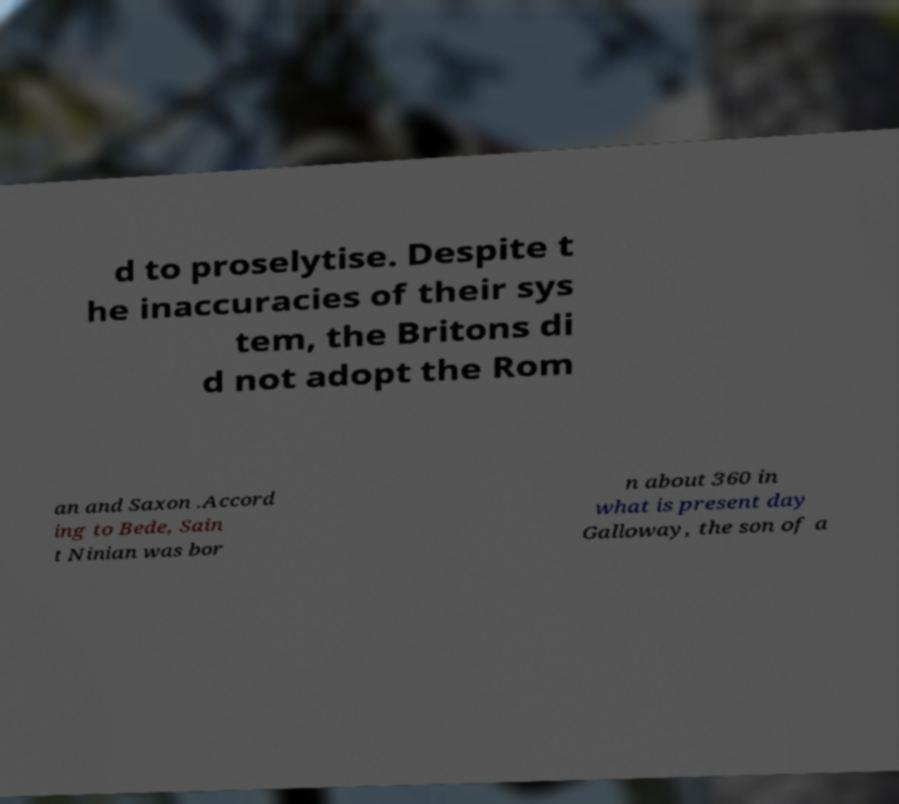Could you extract and type out the text from this image? d to proselytise. Despite t he inaccuracies of their sys tem, the Britons di d not adopt the Rom an and Saxon .Accord ing to Bede, Sain t Ninian was bor n about 360 in what is present day Galloway, the son of a 